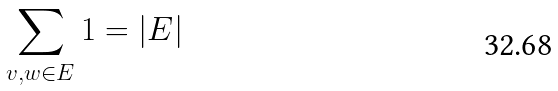<formula> <loc_0><loc_0><loc_500><loc_500>\sum _ { v , w \in E } 1 = | E |</formula> 